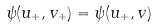<formula> <loc_0><loc_0><loc_500><loc_500>\psi ( u _ { + } , v _ { + } ) = \psi ( u _ { + } , v )</formula> 